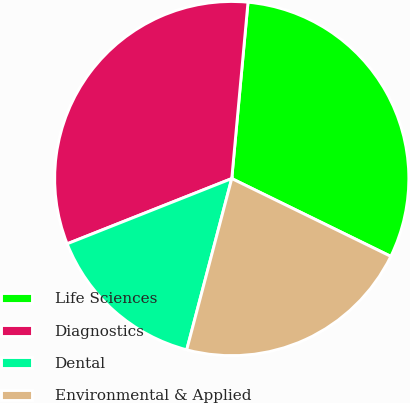<chart> <loc_0><loc_0><loc_500><loc_500><pie_chart><fcel>Life Sciences<fcel>Diagnostics<fcel>Dental<fcel>Environmental & Applied<nl><fcel>30.78%<fcel>32.47%<fcel>14.9%<fcel>21.85%<nl></chart> 